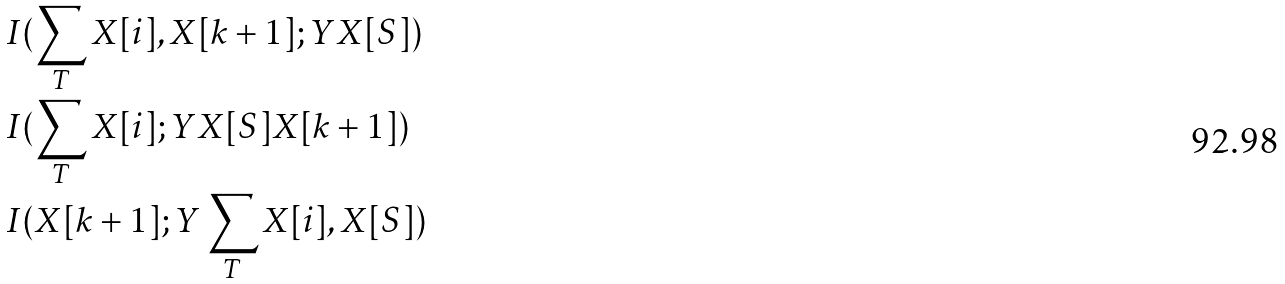<formula> <loc_0><loc_0><loc_500><loc_500>& I ( \sum _ { T } X [ i ] , X [ k + 1 ] ; Y X [ S ] ) \\ & I ( \sum _ { T } X [ i ] ; Y X [ S ] X [ k + 1 ] ) \\ & I ( X [ k + 1 ] ; Y \sum _ { T } X [ i ] , X [ S ] )</formula> 